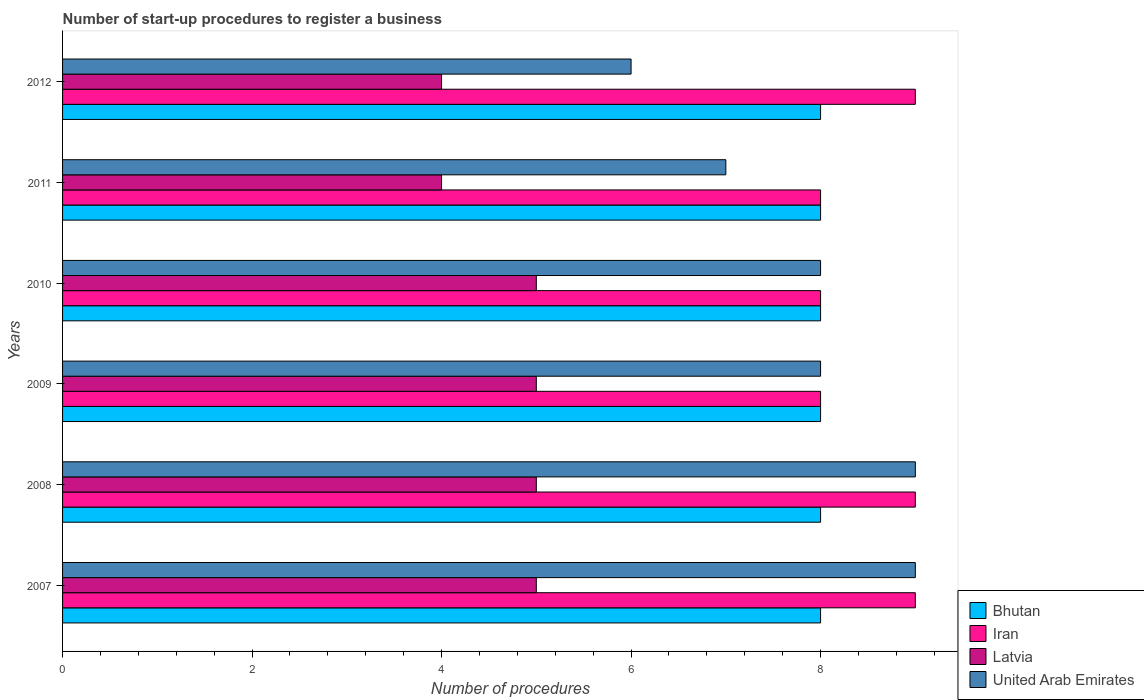Are the number of bars on each tick of the Y-axis equal?
Your answer should be compact. Yes. How many bars are there on the 4th tick from the top?
Your response must be concise. 4. How many bars are there on the 4th tick from the bottom?
Provide a succinct answer. 4. What is the label of the 1st group of bars from the top?
Offer a very short reply. 2012. What is the number of procedures required to register a business in Bhutan in 2011?
Keep it short and to the point. 8. Across all years, what is the maximum number of procedures required to register a business in Bhutan?
Ensure brevity in your answer.  8. Across all years, what is the minimum number of procedures required to register a business in Latvia?
Keep it short and to the point. 4. What is the total number of procedures required to register a business in Latvia in the graph?
Your answer should be very brief. 28. What is the difference between the number of procedures required to register a business in Latvia in 2011 and the number of procedures required to register a business in Bhutan in 2012?
Provide a succinct answer. -4. What is the average number of procedures required to register a business in Iran per year?
Ensure brevity in your answer.  8.5. In the year 2007, what is the difference between the number of procedures required to register a business in Bhutan and number of procedures required to register a business in Latvia?
Ensure brevity in your answer.  3. Is the number of procedures required to register a business in United Arab Emirates in 2009 less than that in 2012?
Provide a succinct answer. No. Is the difference between the number of procedures required to register a business in Bhutan in 2011 and 2012 greater than the difference between the number of procedures required to register a business in Latvia in 2011 and 2012?
Offer a terse response. No. What is the difference between the highest and the second highest number of procedures required to register a business in United Arab Emirates?
Keep it short and to the point. 0. What is the difference between the highest and the lowest number of procedures required to register a business in Iran?
Make the answer very short. 1. In how many years, is the number of procedures required to register a business in Latvia greater than the average number of procedures required to register a business in Latvia taken over all years?
Keep it short and to the point. 4. Is the sum of the number of procedures required to register a business in United Arab Emirates in 2007 and 2009 greater than the maximum number of procedures required to register a business in Iran across all years?
Offer a very short reply. Yes. Is it the case that in every year, the sum of the number of procedures required to register a business in Iran and number of procedures required to register a business in Latvia is greater than the sum of number of procedures required to register a business in Bhutan and number of procedures required to register a business in United Arab Emirates?
Your response must be concise. Yes. What does the 2nd bar from the top in 2007 represents?
Your response must be concise. Latvia. What does the 1st bar from the bottom in 2008 represents?
Provide a short and direct response. Bhutan. Are the values on the major ticks of X-axis written in scientific E-notation?
Your answer should be compact. No. Does the graph contain grids?
Make the answer very short. No. How are the legend labels stacked?
Provide a succinct answer. Vertical. What is the title of the graph?
Your response must be concise. Number of start-up procedures to register a business. Does "Antigua and Barbuda" appear as one of the legend labels in the graph?
Keep it short and to the point. No. What is the label or title of the X-axis?
Make the answer very short. Number of procedures. What is the label or title of the Y-axis?
Provide a succinct answer. Years. What is the Number of procedures of Iran in 2007?
Your answer should be very brief. 9. What is the Number of procedures of Bhutan in 2008?
Provide a short and direct response. 8. What is the Number of procedures of Iran in 2008?
Your response must be concise. 9. What is the Number of procedures in Latvia in 2008?
Keep it short and to the point. 5. What is the Number of procedures in Latvia in 2009?
Give a very brief answer. 5. What is the Number of procedures of United Arab Emirates in 2009?
Keep it short and to the point. 8. What is the Number of procedures in Iran in 2010?
Your answer should be very brief. 8. What is the Number of procedures in United Arab Emirates in 2010?
Offer a very short reply. 8. What is the Number of procedures in Bhutan in 2011?
Provide a succinct answer. 8. What is the Number of procedures of Latvia in 2011?
Provide a succinct answer. 4. What is the Number of procedures of Latvia in 2012?
Your response must be concise. 4. What is the Number of procedures in United Arab Emirates in 2012?
Provide a short and direct response. 6. Across all years, what is the minimum Number of procedures in Iran?
Your response must be concise. 8. Across all years, what is the minimum Number of procedures in Latvia?
Provide a short and direct response. 4. Across all years, what is the minimum Number of procedures of United Arab Emirates?
Make the answer very short. 6. What is the total Number of procedures in Iran in the graph?
Your response must be concise. 51. What is the difference between the Number of procedures of Bhutan in 2007 and that in 2009?
Your answer should be compact. 0. What is the difference between the Number of procedures in United Arab Emirates in 2007 and that in 2010?
Ensure brevity in your answer.  1. What is the difference between the Number of procedures in Bhutan in 2007 and that in 2011?
Provide a short and direct response. 0. What is the difference between the Number of procedures of Iran in 2007 and that in 2011?
Your answer should be compact. 1. What is the difference between the Number of procedures of Latvia in 2007 and that in 2011?
Offer a terse response. 1. What is the difference between the Number of procedures of United Arab Emirates in 2007 and that in 2011?
Offer a very short reply. 2. What is the difference between the Number of procedures in Iran in 2007 and that in 2012?
Your answer should be very brief. 0. What is the difference between the Number of procedures of United Arab Emirates in 2007 and that in 2012?
Keep it short and to the point. 3. What is the difference between the Number of procedures in Bhutan in 2008 and that in 2009?
Your answer should be compact. 0. What is the difference between the Number of procedures of Latvia in 2008 and that in 2010?
Your response must be concise. 0. What is the difference between the Number of procedures in United Arab Emirates in 2008 and that in 2010?
Your response must be concise. 1. What is the difference between the Number of procedures in Bhutan in 2008 and that in 2011?
Keep it short and to the point. 0. What is the difference between the Number of procedures of Bhutan in 2008 and that in 2012?
Give a very brief answer. 0. What is the difference between the Number of procedures in Iran in 2008 and that in 2012?
Offer a terse response. 0. What is the difference between the Number of procedures of Latvia in 2008 and that in 2012?
Your answer should be compact. 1. What is the difference between the Number of procedures in Iran in 2009 and that in 2010?
Offer a terse response. 0. What is the difference between the Number of procedures in Latvia in 2009 and that in 2010?
Offer a very short reply. 0. What is the difference between the Number of procedures in United Arab Emirates in 2009 and that in 2010?
Make the answer very short. 0. What is the difference between the Number of procedures of Bhutan in 2009 and that in 2011?
Offer a terse response. 0. What is the difference between the Number of procedures in Latvia in 2009 and that in 2011?
Ensure brevity in your answer.  1. What is the difference between the Number of procedures of United Arab Emirates in 2009 and that in 2011?
Offer a terse response. 1. What is the difference between the Number of procedures of Bhutan in 2009 and that in 2012?
Ensure brevity in your answer.  0. What is the difference between the Number of procedures in Bhutan in 2010 and that in 2011?
Your answer should be compact. 0. What is the difference between the Number of procedures of Iran in 2010 and that in 2011?
Make the answer very short. 0. What is the difference between the Number of procedures of Latvia in 2010 and that in 2011?
Your response must be concise. 1. What is the difference between the Number of procedures in United Arab Emirates in 2010 and that in 2011?
Offer a terse response. 1. What is the difference between the Number of procedures of Bhutan in 2011 and that in 2012?
Give a very brief answer. 0. What is the difference between the Number of procedures of Iran in 2011 and that in 2012?
Offer a terse response. -1. What is the difference between the Number of procedures in Bhutan in 2007 and the Number of procedures in Iran in 2008?
Keep it short and to the point. -1. What is the difference between the Number of procedures of Bhutan in 2007 and the Number of procedures of Latvia in 2008?
Ensure brevity in your answer.  3. What is the difference between the Number of procedures of Iran in 2007 and the Number of procedures of Latvia in 2008?
Your response must be concise. 4. What is the difference between the Number of procedures of Latvia in 2007 and the Number of procedures of United Arab Emirates in 2008?
Make the answer very short. -4. What is the difference between the Number of procedures of Bhutan in 2007 and the Number of procedures of Iran in 2009?
Your response must be concise. 0. What is the difference between the Number of procedures in Bhutan in 2007 and the Number of procedures in United Arab Emirates in 2009?
Offer a very short reply. 0. What is the difference between the Number of procedures in Iran in 2007 and the Number of procedures in Latvia in 2009?
Offer a very short reply. 4. What is the difference between the Number of procedures in Bhutan in 2007 and the Number of procedures in Iran in 2010?
Your response must be concise. 0. What is the difference between the Number of procedures of Bhutan in 2007 and the Number of procedures of Latvia in 2010?
Offer a very short reply. 3. What is the difference between the Number of procedures in Latvia in 2007 and the Number of procedures in United Arab Emirates in 2010?
Provide a short and direct response. -3. What is the difference between the Number of procedures in Bhutan in 2007 and the Number of procedures in Iran in 2011?
Offer a terse response. 0. What is the difference between the Number of procedures of Iran in 2007 and the Number of procedures of United Arab Emirates in 2011?
Give a very brief answer. 2. What is the difference between the Number of procedures in Bhutan in 2007 and the Number of procedures in Iran in 2012?
Your answer should be compact. -1. What is the difference between the Number of procedures in Bhutan in 2007 and the Number of procedures in Latvia in 2012?
Ensure brevity in your answer.  4. What is the difference between the Number of procedures in Bhutan in 2007 and the Number of procedures in United Arab Emirates in 2012?
Give a very brief answer. 2. What is the difference between the Number of procedures in Iran in 2007 and the Number of procedures in Latvia in 2012?
Ensure brevity in your answer.  5. What is the difference between the Number of procedures of Iran in 2007 and the Number of procedures of United Arab Emirates in 2012?
Keep it short and to the point. 3. What is the difference between the Number of procedures in Bhutan in 2008 and the Number of procedures in Latvia in 2009?
Give a very brief answer. 3. What is the difference between the Number of procedures in Latvia in 2008 and the Number of procedures in United Arab Emirates in 2009?
Your answer should be compact. -3. What is the difference between the Number of procedures in Bhutan in 2008 and the Number of procedures in Iran in 2010?
Provide a succinct answer. 0. What is the difference between the Number of procedures of Bhutan in 2008 and the Number of procedures of Latvia in 2010?
Give a very brief answer. 3. What is the difference between the Number of procedures of Iran in 2008 and the Number of procedures of Latvia in 2010?
Give a very brief answer. 4. What is the difference between the Number of procedures in Iran in 2008 and the Number of procedures in United Arab Emirates in 2010?
Your answer should be compact. 1. What is the difference between the Number of procedures in Bhutan in 2008 and the Number of procedures in Iran in 2011?
Provide a succinct answer. 0. What is the difference between the Number of procedures in Bhutan in 2008 and the Number of procedures in Latvia in 2011?
Your answer should be compact. 4. What is the difference between the Number of procedures of Bhutan in 2008 and the Number of procedures of United Arab Emirates in 2011?
Provide a short and direct response. 1. What is the difference between the Number of procedures in Iran in 2008 and the Number of procedures in Latvia in 2011?
Your response must be concise. 5. What is the difference between the Number of procedures in Latvia in 2008 and the Number of procedures in United Arab Emirates in 2011?
Offer a very short reply. -2. What is the difference between the Number of procedures in Bhutan in 2008 and the Number of procedures in Iran in 2012?
Give a very brief answer. -1. What is the difference between the Number of procedures in Bhutan in 2008 and the Number of procedures in Latvia in 2012?
Ensure brevity in your answer.  4. What is the difference between the Number of procedures of Iran in 2008 and the Number of procedures of Latvia in 2012?
Provide a succinct answer. 5. What is the difference between the Number of procedures in Bhutan in 2009 and the Number of procedures in United Arab Emirates in 2010?
Make the answer very short. 0. What is the difference between the Number of procedures in Latvia in 2009 and the Number of procedures in United Arab Emirates in 2010?
Offer a very short reply. -3. What is the difference between the Number of procedures in Bhutan in 2009 and the Number of procedures in Latvia in 2011?
Offer a very short reply. 4. What is the difference between the Number of procedures of Bhutan in 2009 and the Number of procedures of United Arab Emirates in 2011?
Make the answer very short. 1. What is the difference between the Number of procedures of Iran in 2009 and the Number of procedures of Latvia in 2011?
Your response must be concise. 4. What is the difference between the Number of procedures in Iran in 2009 and the Number of procedures in United Arab Emirates in 2011?
Provide a short and direct response. 1. What is the difference between the Number of procedures of Latvia in 2009 and the Number of procedures of United Arab Emirates in 2011?
Your response must be concise. -2. What is the difference between the Number of procedures of Bhutan in 2009 and the Number of procedures of Iran in 2012?
Offer a very short reply. -1. What is the difference between the Number of procedures in Bhutan in 2009 and the Number of procedures in United Arab Emirates in 2012?
Give a very brief answer. 2. What is the difference between the Number of procedures in Iran in 2009 and the Number of procedures in United Arab Emirates in 2012?
Offer a very short reply. 2. What is the difference between the Number of procedures of Latvia in 2009 and the Number of procedures of United Arab Emirates in 2012?
Your answer should be compact. -1. What is the difference between the Number of procedures of Bhutan in 2010 and the Number of procedures of Latvia in 2011?
Keep it short and to the point. 4. What is the difference between the Number of procedures of Latvia in 2010 and the Number of procedures of United Arab Emirates in 2011?
Your response must be concise. -2. What is the difference between the Number of procedures in Bhutan in 2010 and the Number of procedures in Latvia in 2012?
Your response must be concise. 4. What is the difference between the Number of procedures in Iran in 2010 and the Number of procedures in Latvia in 2012?
Offer a terse response. 4. What is the difference between the Number of procedures in Latvia in 2010 and the Number of procedures in United Arab Emirates in 2012?
Your answer should be very brief. -1. What is the difference between the Number of procedures in Bhutan in 2011 and the Number of procedures in Latvia in 2012?
Offer a very short reply. 4. What is the difference between the Number of procedures of Iran in 2011 and the Number of procedures of United Arab Emirates in 2012?
Your answer should be compact. 2. What is the average Number of procedures of Iran per year?
Your answer should be very brief. 8.5. What is the average Number of procedures of Latvia per year?
Your response must be concise. 4.67. What is the average Number of procedures of United Arab Emirates per year?
Offer a very short reply. 7.83. In the year 2007, what is the difference between the Number of procedures of Bhutan and Number of procedures of Iran?
Your response must be concise. -1. In the year 2007, what is the difference between the Number of procedures of Bhutan and Number of procedures of Latvia?
Your answer should be compact. 3. In the year 2007, what is the difference between the Number of procedures of Bhutan and Number of procedures of United Arab Emirates?
Ensure brevity in your answer.  -1. In the year 2007, what is the difference between the Number of procedures in Iran and Number of procedures in Latvia?
Provide a short and direct response. 4. In the year 2008, what is the difference between the Number of procedures of Bhutan and Number of procedures of Latvia?
Ensure brevity in your answer.  3. In the year 2008, what is the difference between the Number of procedures of Iran and Number of procedures of Latvia?
Offer a very short reply. 4. In the year 2009, what is the difference between the Number of procedures in Bhutan and Number of procedures in Latvia?
Give a very brief answer. 3. In the year 2009, what is the difference between the Number of procedures of Iran and Number of procedures of Latvia?
Provide a succinct answer. 3. In the year 2009, what is the difference between the Number of procedures of Iran and Number of procedures of United Arab Emirates?
Give a very brief answer. 0. In the year 2009, what is the difference between the Number of procedures of Latvia and Number of procedures of United Arab Emirates?
Your answer should be compact. -3. In the year 2010, what is the difference between the Number of procedures of Bhutan and Number of procedures of Iran?
Provide a succinct answer. 0. In the year 2010, what is the difference between the Number of procedures of Bhutan and Number of procedures of United Arab Emirates?
Provide a short and direct response. 0. In the year 2010, what is the difference between the Number of procedures in Latvia and Number of procedures in United Arab Emirates?
Your response must be concise. -3. In the year 2011, what is the difference between the Number of procedures in Bhutan and Number of procedures in Latvia?
Your answer should be compact. 4. In the year 2011, what is the difference between the Number of procedures in Bhutan and Number of procedures in United Arab Emirates?
Offer a very short reply. 1. In the year 2011, what is the difference between the Number of procedures of Iran and Number of procedures of Latvia?
Your answer should be compact. 4. In the year 2011, what is the difference between the Number of procedures in Iran and Number of procedures in United Arab Emirates?
Make the answer very short. 1. In the year 2011, what is the difference between the Number of procedures in Latvia and Number of procedures in United Arab Emirates?
Provide a short and direct response. -3. In the year 2012, what is the difference between the Number of procedures in Bhutan and Number of procedures in Iran?
Ensure brevity in your answer.  -1. In the year 2012, what is the difference between the Number of procedures in Bhutan and Number of procedures in Latvia?
Make the answer very short. 4. In the year 2012, what is the difference between the Number of procedures in Bhutan and Number of procedures in United Arab Emirates?
Provide a short and direct response. 2. In the year 2012, what is the difference between the Number of procedures in Iran and Number of procedures in United Arab Emirates?
Make the answer very short. 3. In the year 2012, what is the difference between the Number of procedures in Latvia and Number of procedures in United Arab Emirates?
Offer a terse response. -2. What is the ratio of the Number of procedures of Bhutan in 2007 to that in 2008?
Provide a succinct answer. 1. What is the ratio of the Number of procedures in Iran in 2007 to that in 2008?
Provide a succinct answer. 1. What is the ratio of the Number of procedures in Latvia in 2007 to that in 2008?
Provide a succinct answer. 1. What is the ratio of the Number of procedures in Bhutan in 2007 to that in 2009?
Your answer should be compact. 1. What is the ratio of the Number of procedures in Latvia in 2007 to that in 2009?
Give a very brief answer. 1. What is the ratio of the Number of procedures in Iran in 2007 to that in 2010?
Offer a very short reply. 1.12. What is the ratio of the Number of procedures in Latvia in 2007 to that in 2010?
Offer a terse response. 1. What is the ratio of the Number of procedures of United Arab Emirates in 2007 to that in 2010?
Your answer should be very brief. 1.12. What is the ratio of the Number of procedures of Iran in 2007 to that in 2011?
Offer a very short reply. 1.12. What is the ratio of the Number of procedures in Latvia in 2007 to that in 2011?
Your answer should be compact. 1.25. What is the ratio of the Number of procedures of United Arab Emirates in 2007 to that in 2011?
Provide a succinct answer. 1.29. What is the ratio of the Number of procedures of Iran in 2007 to that in 2012?
Keep it short and to the point. 1. What is the ratio of the Number of procedures of Bhutan in 2008 to that in 2012?
Offer a terse response. 1. What is the ratio of the Number of procedures in Iran in 2008 to that in 2012?
Your response must be concise. 1. What is the ratio of the Number of procedures in Latvia in 2008 to that in 2012?
Offer a terse response. 1.25. What is the ratio of the Number of procedures of Bhutan in 2009 to that in 2010?
Provide a succinct answer. 1. What is the ratio of the Number of procedures in Iran in 2009 to that in 2010?
Your response must be concise. 1. What is the ratio of the Number of procedures of Latvia in 2009 to that in 2011?
Your response must be concise. 1.25. What is the ratio of the Number of procedures in United Arab Emirates in 2009 to that in 2011?
Keep it short and to the point. 1.14. What is the ratio of the Number of procedures of Iran in 2009 to that in 2012?
Give a very brief answer. 0.89. What is the ratio of the Number of procedures in Iran in 2010 to that in 2011?
Ensure brevity in your answer.  1. What is the difference between the highest and the second highest Number of procedures in Bhutan?
Provide a short and direct response. 0. What is the difference between the highest and the second highest Number of procedures of Latvia?
Your answer should be very brief. 0. What is the difference between the highest and the second highest Number of procedures of United Arab Emirates?
Offer a terse response. 0. What is the difference between the highest and the lowest Number of procedures of Bhutan?
Keep it short and to the point. 0. What is the difference between the highest and the lowest Number of procedures in Latvia?
Your response must be concise. 1. What is the difference between the highest and the lowest Number of procedures in United Arab Emirates?
Ensure brevity in your answer.  3. 